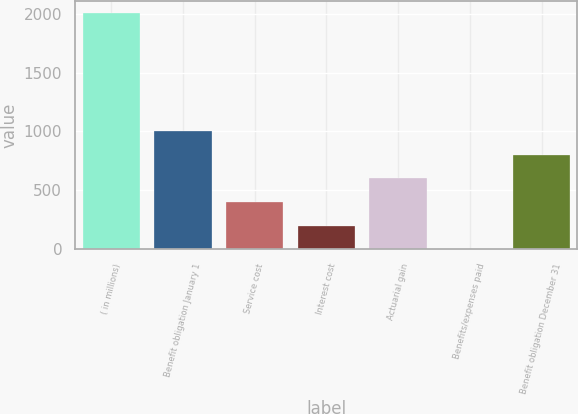Convert chart to OTSL. <chart><loc_0><loc_0><loc_500><loc_500><bar_chart><fcel>( in millions)<fcel>Benefit obligation January 1<fcel>Service cost<fcel>Interest cost<fcel>Actuarial gain<fcel>Benefits/expenses paid<fcel>Benefit obligation December 31<nl><fcel>2007<fcel>1003.9<fcel>402.04<fcel>201.42<fcel>602.66<fcel>0.8<fcel>803.28<nl></chart> 